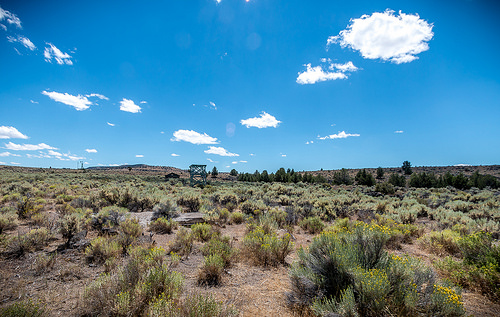<image>
Is the bush next to the bush? Yes. The bush is positioned adjacent to the bush, located nearby in the same general area. 